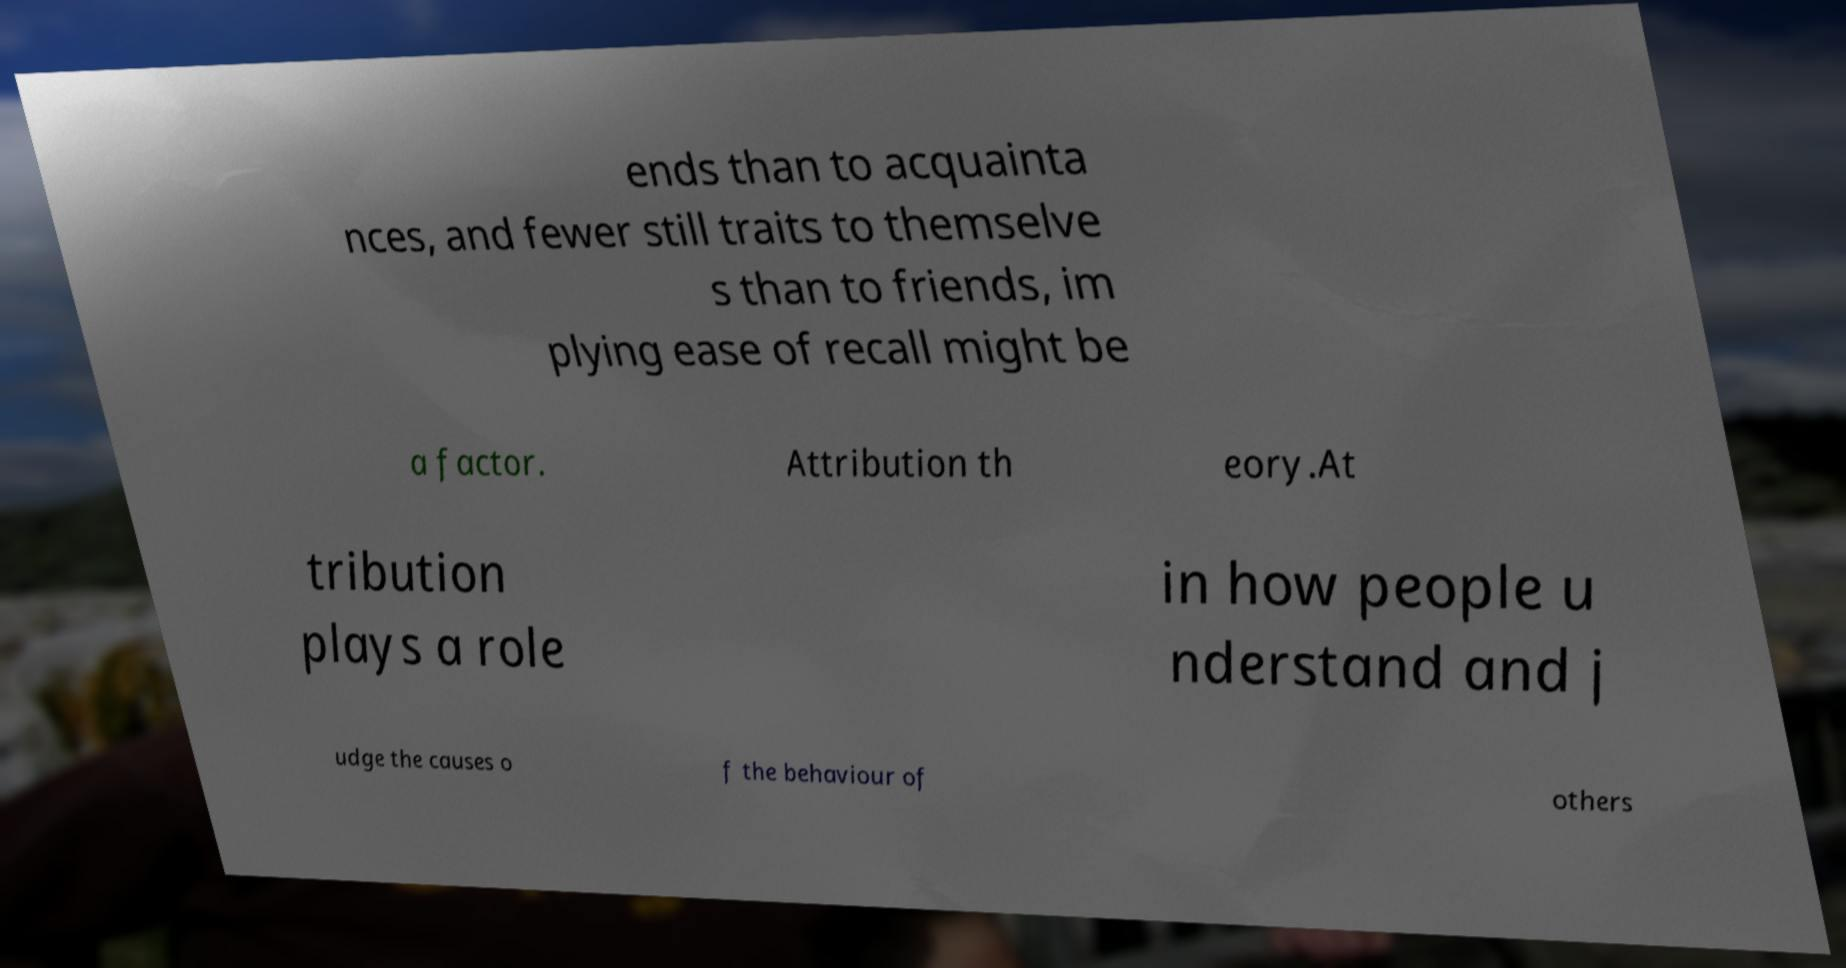What messages or text are displayed in this image? I need them in a readable, typed format. ends than to acquainta nces, and fewer still traits to themselve s than to friends, im plying ease of recall might be a factor. Attribution th eory.At tribution plays a role in how people u nderstand and j udge the causes o f the behaviour of others 